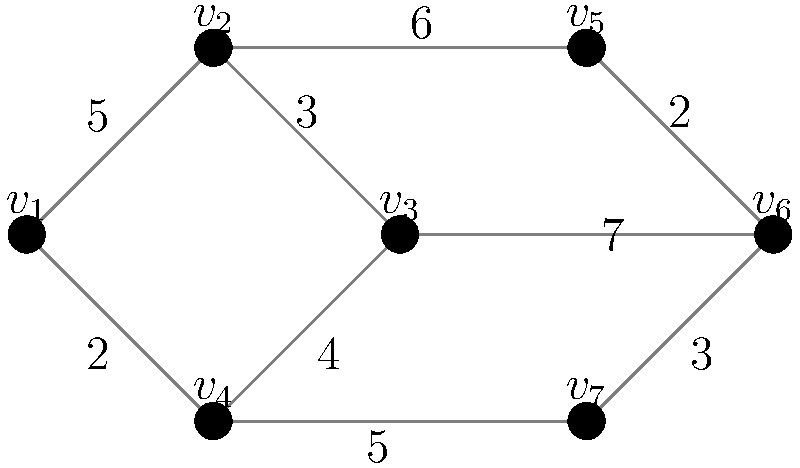As a spy tasked with optimizing encrypted communication networks, you need to establish a secure connection between all nodes while minimizing the total encryption cost. Given the graph where vertices represent communication nodes and edge weights represent encryption costs, what is the minimum total cost to connect all nodes securely? (Hint: Consider using a minimum spanning tree algorithm.) To solve this problem, we need to find the Minimum Spanning Tree (MST) of the given graph. The MST will connect all nodes with the minimum total edge weight, which represents the minimum total encryption cost in this scenario. We can use Kruskal's algorithm to find the MST:

1. Sort all edges by weight in ascending order:
   (3,0): 2
   (4,5): 2
   (1,2): 3
   (5,6): 3
   (2,3): 4
   (0,1): 5
   (3,6): 5
   (1,4): 6
   (2,5): 7

2. Start with an empty set of edges and add edges in order, skipping those that would create a cycle:
   - Add (3,0): 2
   - Add (4,5): 2
   - Add (1,2): 3
   - Add (5,6): 3
   - Add (2,3): 4
   - Add (0,1): 5

3. After adding these edges, we have connected all vertices without creating any cycles.

4. The total cost of the MST is the sum of the selected edge weights:
   2 + 2 + 3 + 3 + 4 + 5 = 19

Therefore, the minimum total encryption cost to securely connect all nodes is 19.
Answer: 19 